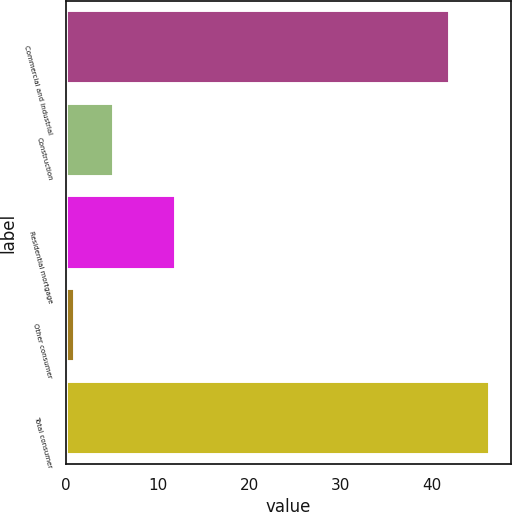Convert chart to OTSL. <chart><loc_0><loc_0><loc_500><loc_500><bar_chart><fcel>Commercial and industrial<fcel>Construction<fcel>Residential mortgage<fcel>Other consumer<fcel>Total consumer<nl><fcel>42<fcel>5.3<fcel>12<fcel>1<fcel>46.3<nl></chart> 